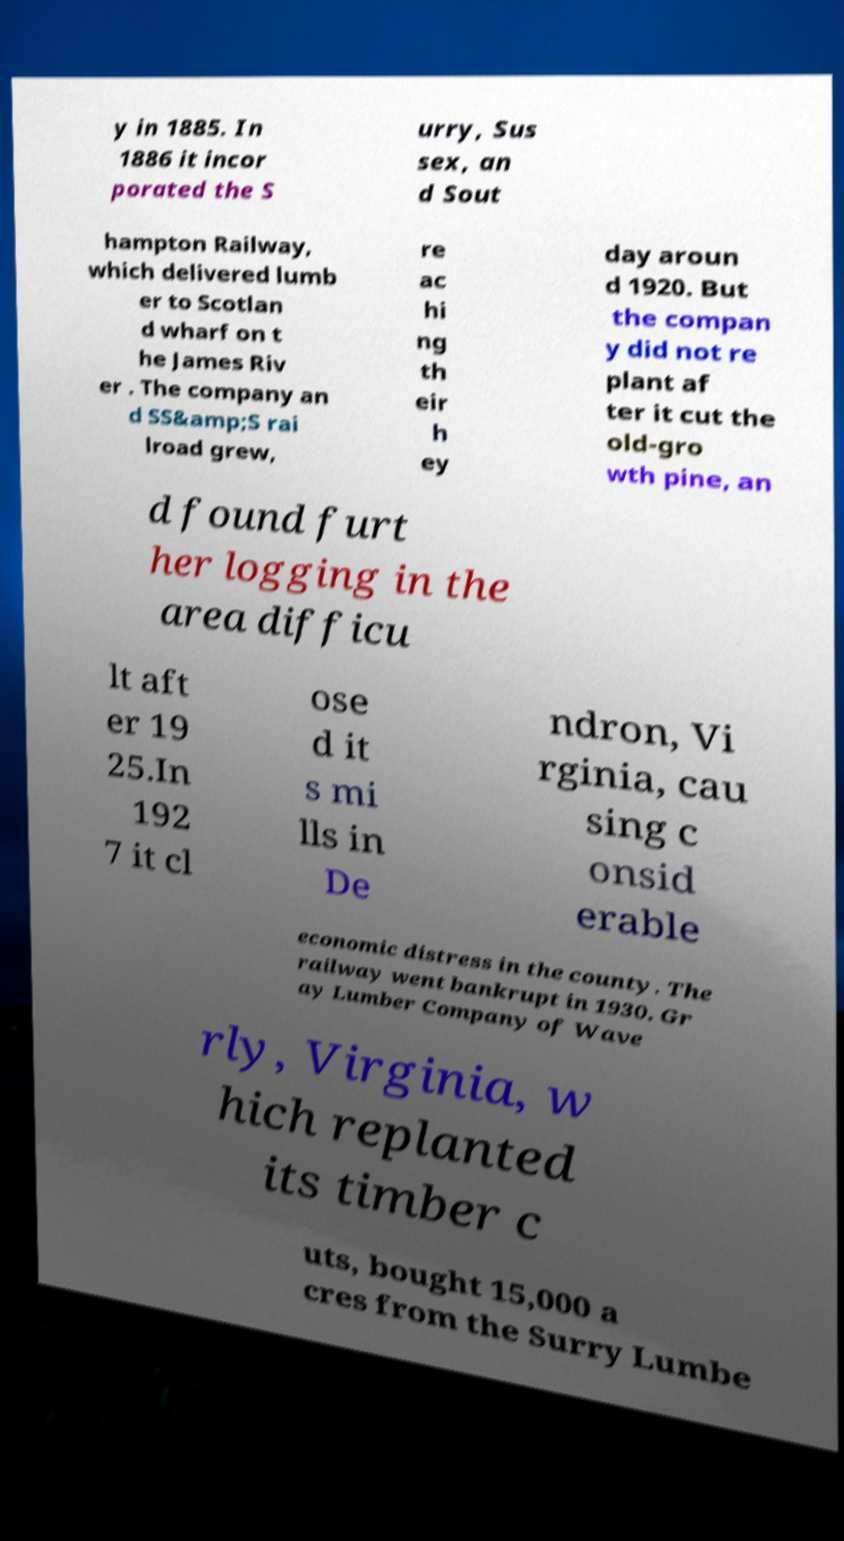Please read and relay the text visible in this image. What does it say? y in 1885. In 1886 it incor porated the S urry, Sus sex, an d Sout hampton Railway, which delivered lumb er to Scotlan d wharf on t he James Riv er . The company an d SS&amp;S rai lroad grew, re ac hi ng th eir h ey day aroun d 1920. But the compan y did not re plant af ter it cut the old-gro wth pine, an d found furt her logging in the area difficu lt aft er 19 25.In 192 7 it cl ose d it s mi lls in De ndron, Vi rginia, cau sing c onsid erable economic distress in the county. The railway went bankrupt in 1930. Gr ay Lumber Company of Wave rly, Virginia, w hich replanted its timber c uts, bought 15,000 a cres from the Surry Lumbe 